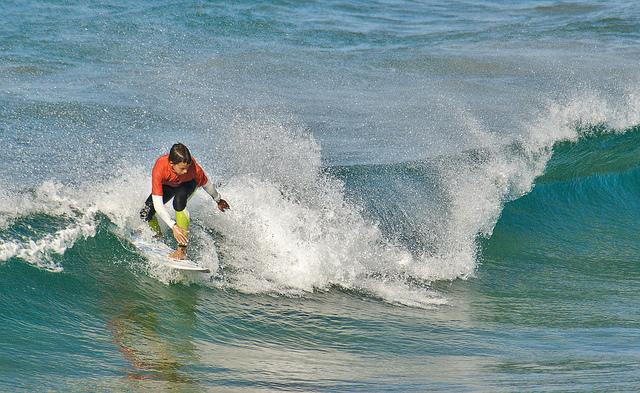What is the person trying to stand on?
Be succinct. Surfboard. What color is the surfboard?
Quick response, please. White. Is this an ocean or a lake?
Keep it brief. Ocean. 